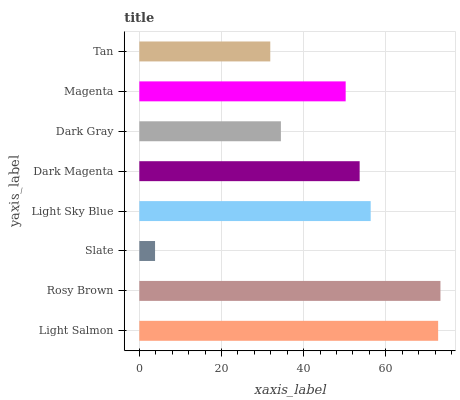Is Slate the minimum?
Answer yes or no. Yes. Is Rosy Brown the maximum?
Answer yes or no. Yes. Is Rosy Brown the minimum?
Answer yes or no. No. Is Slate the maximum?
Answer yes or no. No. Is Rosy Brown greater than Slate?
Answer yes or no. Yes. Is Slate less than Rosy Brown?
Answer yes or no. Yes. Is Slate greater than Rosy Brown?
Answer yes or no. No. Is Rosy Brown less than Slate?
Answer yes or no. No. Is Dark Magenta the high median?
Answer yes or no. Yes. Is Magenta the low median?
Answer yes or no. Yes. Is Light Sky Blue the high median?
Answer yes or no. No. Is Light Salmon the low median?
Answer yes or no. No. 